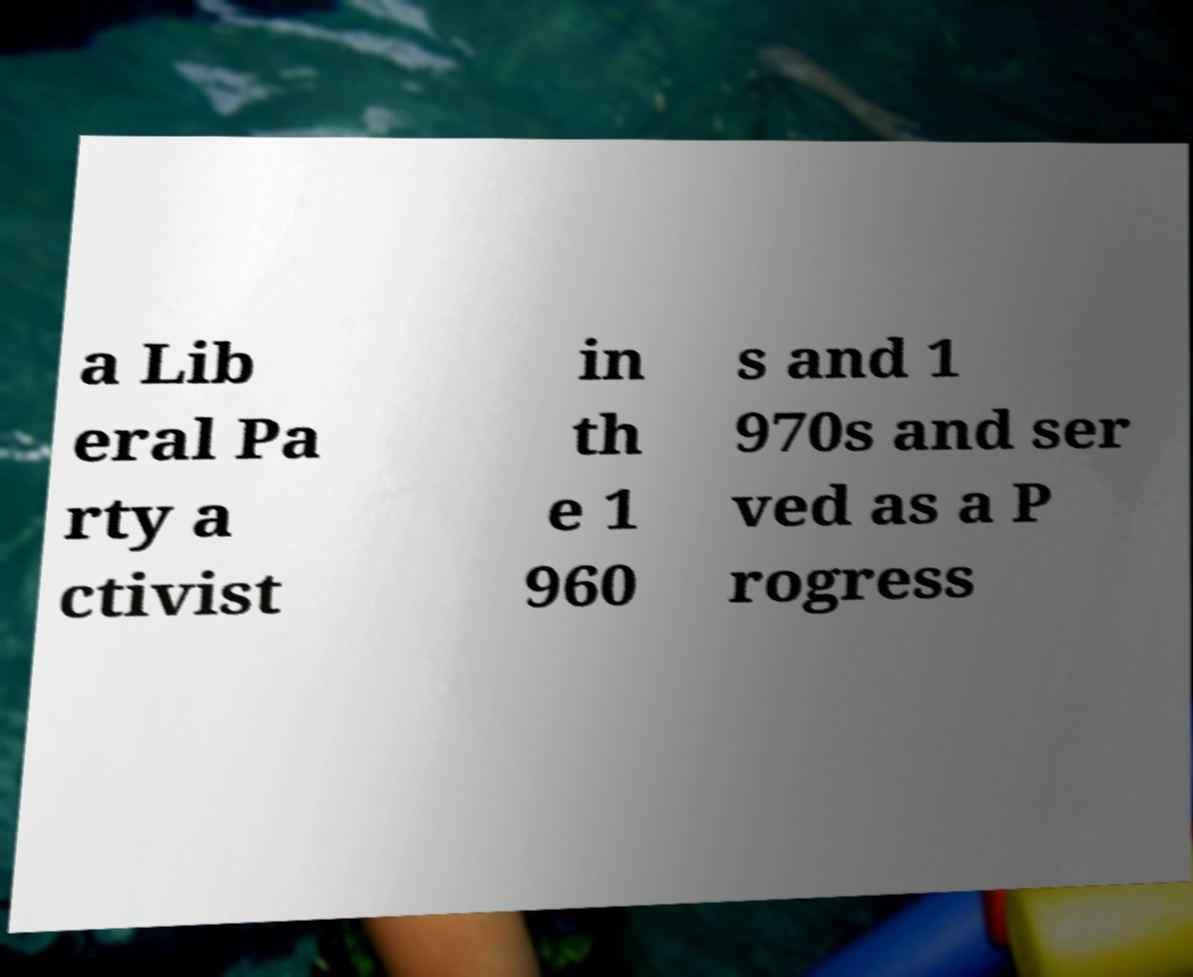Can you accurately transcribe the text from the provided image for me? a Lib eral Pa rty a ctivist in th e 1 960 s and 1 970s and ser ved as a P rogress 